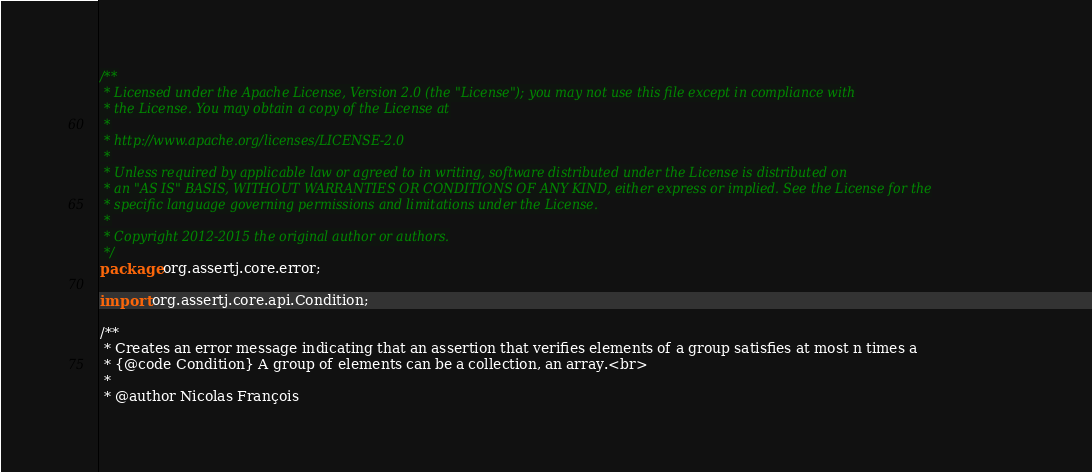<code> <loc_0><loc_0><loc_500><loc_500><_Java_>/**
 * Licensed under the Apache License, Version 2.0 (the "License"); you may not use this file except in compliance with
 * the License. You may obtain a copy of the License at
 *
 * http://www.apache.org/licenses/LICENSE-2.0
 *
 * Unless required by applicable law or agreed to in writing, software distributed under the License is distributed on
 * an "AS IS" BASIS, WITHOUT WARRANTIES OR CONDITIONS OF ANY KIND, either express or implied. See the License for the
 * specific language governing permissions and limitations under the License.
 *
 * Copyright 2012-2015 the original author or authors.
 */
package org.assertj.core.error;

import org.assertj.core.api.Condition;

/**
 * Creates an error message indicating that an assertion that verifies elements of a group satisfies at most n times a
 * {@code Condition} A group of elements can be a collection, an array.<br>
 * 
 * @author Nicolas François</code> 